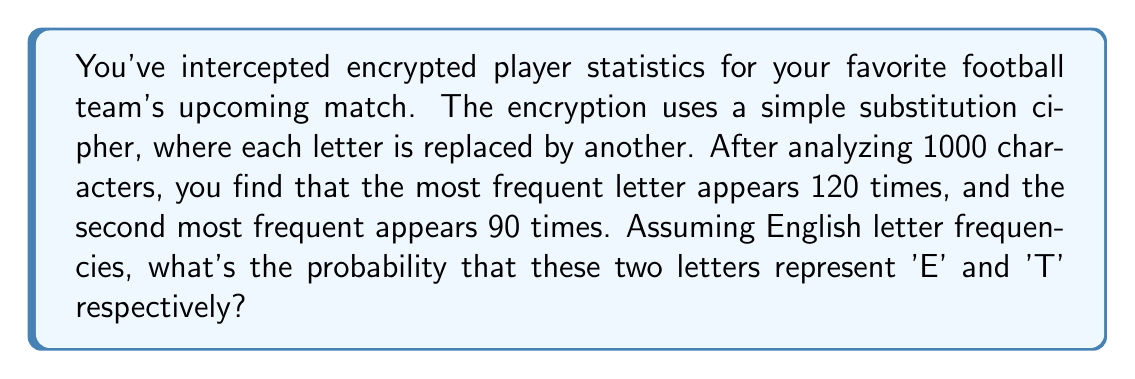Provide a solution to this math problem. Let's approach this step-by-step:

1) In English, 'E' is the most common letter (12.7% frequency) and 'T' is the second most common (9.1% frequency).

2) In our sample of 1000 characters:
   - Most frequent letter: 120/1000 = 12%
   - Second most frequent: 90/1000 = 9%

3) These frequencies are close to the expected frequencies of 'E' and 'T'.

4) To calculate the probability, we can use the binomial distribution:

   $$P(X=k) = \binom{n}{k} p^k (1-p)^{n-k}$$

   where $n$ is the number of trials, $k$ is the number of successes, and $p$ is the probability of success on each trial.

5) For 'E':
   $$P(X=120) = \binom{1000}{120} (0.127)^{120} (0.873)^{880}$$

6) For 'T':
   $$P(X=90) = \binom{1000}{90} (0.091)^{90} (0.909)^{910}$$

7) The probability of both events occurring together is the product of their individual probabilities:

   $$P(\text{E and T}) = P(X=120) \times P(X=90)$$

8) Calculating this gives us approximately 0.0026 or 0.26%.
Answer: 0.26% 